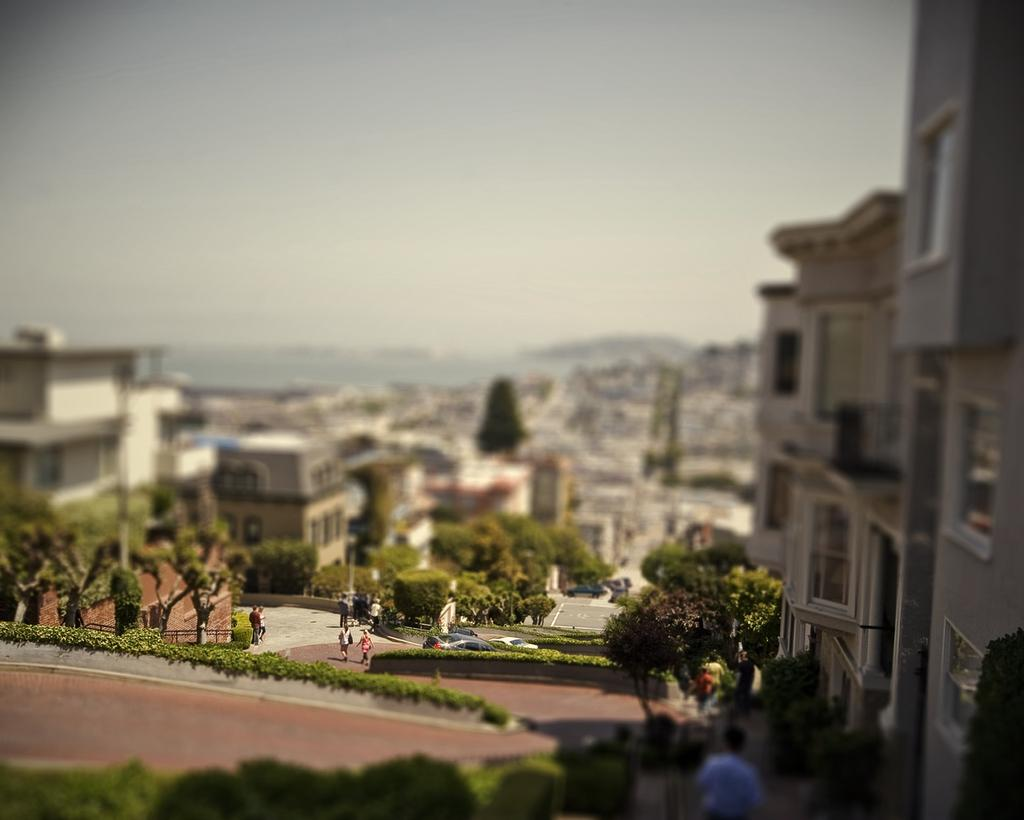What type of natural elements are present in the image? There are many trees and plants in the image. How many people can be seen in the image? There are few people in the image. What part of the environment is visible in the image? The sky is visible in the image. What type of path is present in the image? There is a walkway in the image. What type of chin can be seen on the secretary in the image? There is no secretary or chin present in the image. How many fingers are visible on the person in the image? There is no person or fingers visible in the image. 